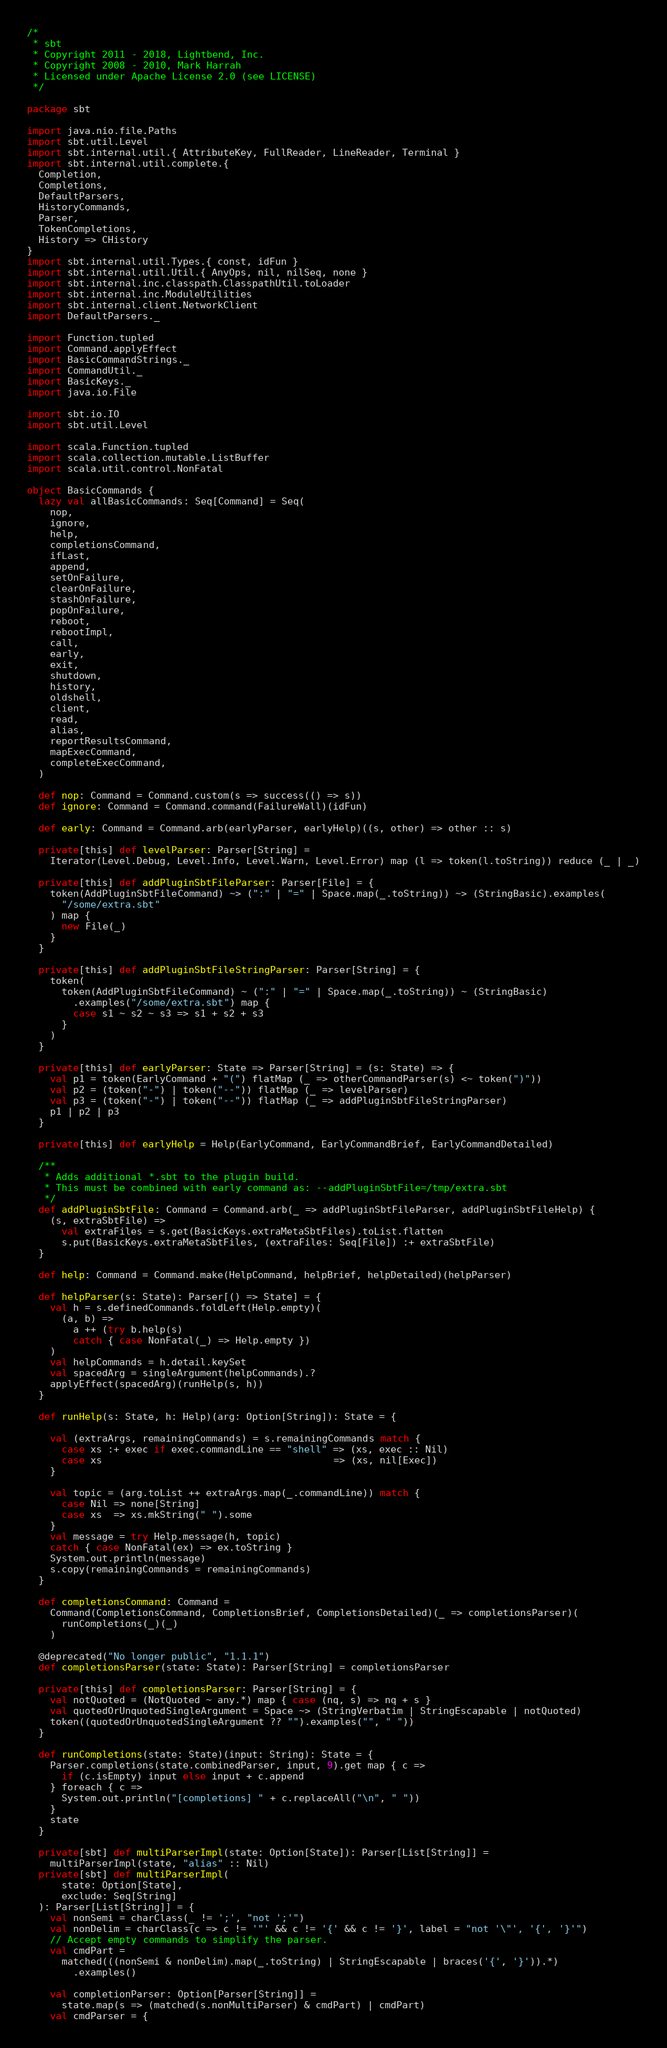Convert code to text. <code><loc_0><loc_0><loc_500><loc_500><_Scala_>/*
 * sbt
 * Copyright 2011 - 2018, Lightbend, Inc.
 * Copyright 2008 - 2010, Mark Harrah
 * Licensed under Apache License 2.0 (see LICENSE)
 */

package sbt

import java.nio.file.Paths
import sbt.util.Level
import sbt.internal.util.{ AttributeKey, FullReader, LineReader, Terminal }
import sbt.internal.util.complete.{
  Completion,
  Completions,
  DefaultParsers,
  HistoryCommands,
  Parser,
  TokenCompletions,
  History => CHistory
}
import sbt.internal.util.Types.{ const, idFun }
import sbt.internal.util.Util.{ AnyOps, nil, nilSeq, none }
import sbt.internal.inc.classpath.ClasspathUtil.toLoader
import sbt.internal.inc.ModuleUtilities
import sbt.internal.client.NetworkClient
import DefaultParsers._

import Function.tupled
import Command.applyEffect
import BasicCommandStrings._
import CommandUtil._
import BasicKeys._
import java.io.File

import sbt.io.IO
import sbt.util.Level

import scala.Function.tupled
import scala.collection.mutable.ListBuffer
import scala.util.control.NonFatal

object BasicCommands {
  lazy val allBasicCommands: Seq[Command] = Seq(
    nop,
    ignore,
    help,
    completionsCommand,
    ifLast,
    append,
    setOnFailure,
    clearOnFailure,
    stashOnFailure,
    popOnFailure,
    reboot,
    rebootImpl,
    call,
    early,
    exit,
    shutdown,
    history,
    oldshell,
    client,
    read,
    alias,
    reportResultsCommand,
    mapExecCommand,
    completeExecCommand,
  )

  def nop: Command = Command.custom(s => success(() => s))
  def ignore: Command = Command.command(FailureWall)(idFun)

  def early: Command = Command.arb(earlyParser, earlyHelp)((s, other) => other :: s)

  private[this] def levelParser: Parser[String] =
    Iterator(Level.Debug, Level.Info, Level.Warn, Level.Error) map (l => token(l.toString)) reduce (_ | _)

  private[this] def addPluginSbtFileParser: Parser[File] = {
    token(AddPluginSbtFileCommand) ~> (":" | "=" | Space.map(_.toString)) ~> (StringBasic).examples(
      "/some/extra.sbt"
    ) map {
      new File(_)
    }
  }

  private[this] def addPluginSbtFileStringParser: Parser[String] = {
    token(
      token(AddPluginSbtFileCommand) ~ (":" | "=" | Space.map(_.toString)) ~ (StringBasic)
        .examples("/some/extra.sbt") map {
        case s1 ~ s2 ~ s3 => s1 + s2 + s3
      }
    )
  }

  private[this] def earlyParser: State => Parser[String] = (s: State) => {
    val p1 = token(EarlyCommand + "(") flatMap (_ => otherCommandParser(s) <~ token(")"))
    val p2 = (token("-") | token("--")) flatMap (_ => levelParser)
    val p3 = (token("-") | token("--")) flatMap (_ => addPluginSbtFileStringParser)
    p1 | p2 | p3
  }

  private[this] def earlyHelp = Help(EarlyCommand, EarlyCommandBrief, EarlyCommandDetailed)

  /**
   * Adds additional *.sbt to the plugin build.
   * This must be combined with early command as: --addPluginSbtFile=/tmp/extra.sbt
   */
  def addPluginSbtFile: Command = Command.arb(_ => addPluginSbtFileParser, addPluginSbtFileHelp) {
    (s, extraSbtFile) =>
      val extraFiles = s.get(BasicKeys.extraMetaSbtFiles).toList.flatten
      s.put(BasicKeys.extraMetaSbtFiles, (extraFiles: Seq[File]) :+ extraSbtFile)
  }

  def help: Command = Command.make(HelpCommand, helpBrief, helpDetailed)(helpParser)

  def helpParser(s: State): Parser[() => State] = {
    val h = s.definedCommands.foldLeft(Help.empty)(
      (a, b) =>
        a ++ (try b.help(s)
        catch { case NonFatal(_) => Help.empty })
    )
    val helpCommands = h.detail.keySet
    val spacedArg = singleArgument(helpCommands).?
    applyEffect(spacedArg)(runHelp(s, h))
  }

  def runHelp(s: State, h: Help)(arg: Option[String]): State = {

    val (extraArgs, remainingCommands) = s.remainingCommands match {
      case xs :+ exec if exec.commandLine == "shell" => (xs, exec :: Nil)
      case xs                                        => (xs, nil[Exec])
    }

    val topic = (arg.toList ++ extraArgs.map(_.commandLine)) match {
      case Nil => none[String]
      case xs  => xs.mkString(" ").some
    }
    val message = try Help.message(h, topic)
    catch { case NonFatal(ex) => ex.toString }
    System.out.println(message)
    s.copy(remainingCommands = remainingCommands)
  }

  def completionsCommand: Command =
    Command(CompletionsCommand, CompletionsBrief, CompletionsDetailed)(_ => completionsParser)(
      runCompletions(_)(_)
    )

  @deprecated("No longer public", "1.1.1")
  def completionsParser(state: State): Parser[String] = completionsParser

  private[this] def completionsParser: Parser[String] = {
    val notQuoted = (NotQuoted ~ any.*) map { case (nq, s) => nq + s }
    val quotedOrUnquotedSingleArgument = Space ~> (StringVerbatim | StringEscapable | notQuoted)
    token((quotedOrUnquotedSingleArgument ?? "").examples("", " "))
  }

  def runCompletions(state: State)(input: String): State = {
    Parser.completions(state.combinedParser, input, 9).get map { c =>
      if (c.isEmpty) input else input + c.append
    } foreach { c =>
      System.out.println("[completions] " + c.replaceAll("\n", " "))
    }
    state
  }

  private[sbt] def multiParserImpl(state: Option[State]): Parser[List[String]] =
    multiParserImpl(state, "alias" :: Nil)
  private[sbt] def multiParserImpl(
      state: Option[State],
      exclude: Seq[String]
  ): Parser[List[String]] = {
    val nonSemi = charClass(_ != ';', "not ';'")
    val nonDelim = charClass(c => c != '"' && c != '{' && c != '}', label = "not '\"', '{', '}'")
    // Accept empty commands to simplify the parser.
    val cmdPart =
      matched(((nonSemi & nonDelim).map(_.toString) | StringEscapable | braces('{', '}')).*)
        .examples()

    val completionParser: Option[Parser[String]] =
      state.map(s => (matched(s.nonMultiParser) & cmdPart) | cmdPart)
    val cmdParser = {</code> 